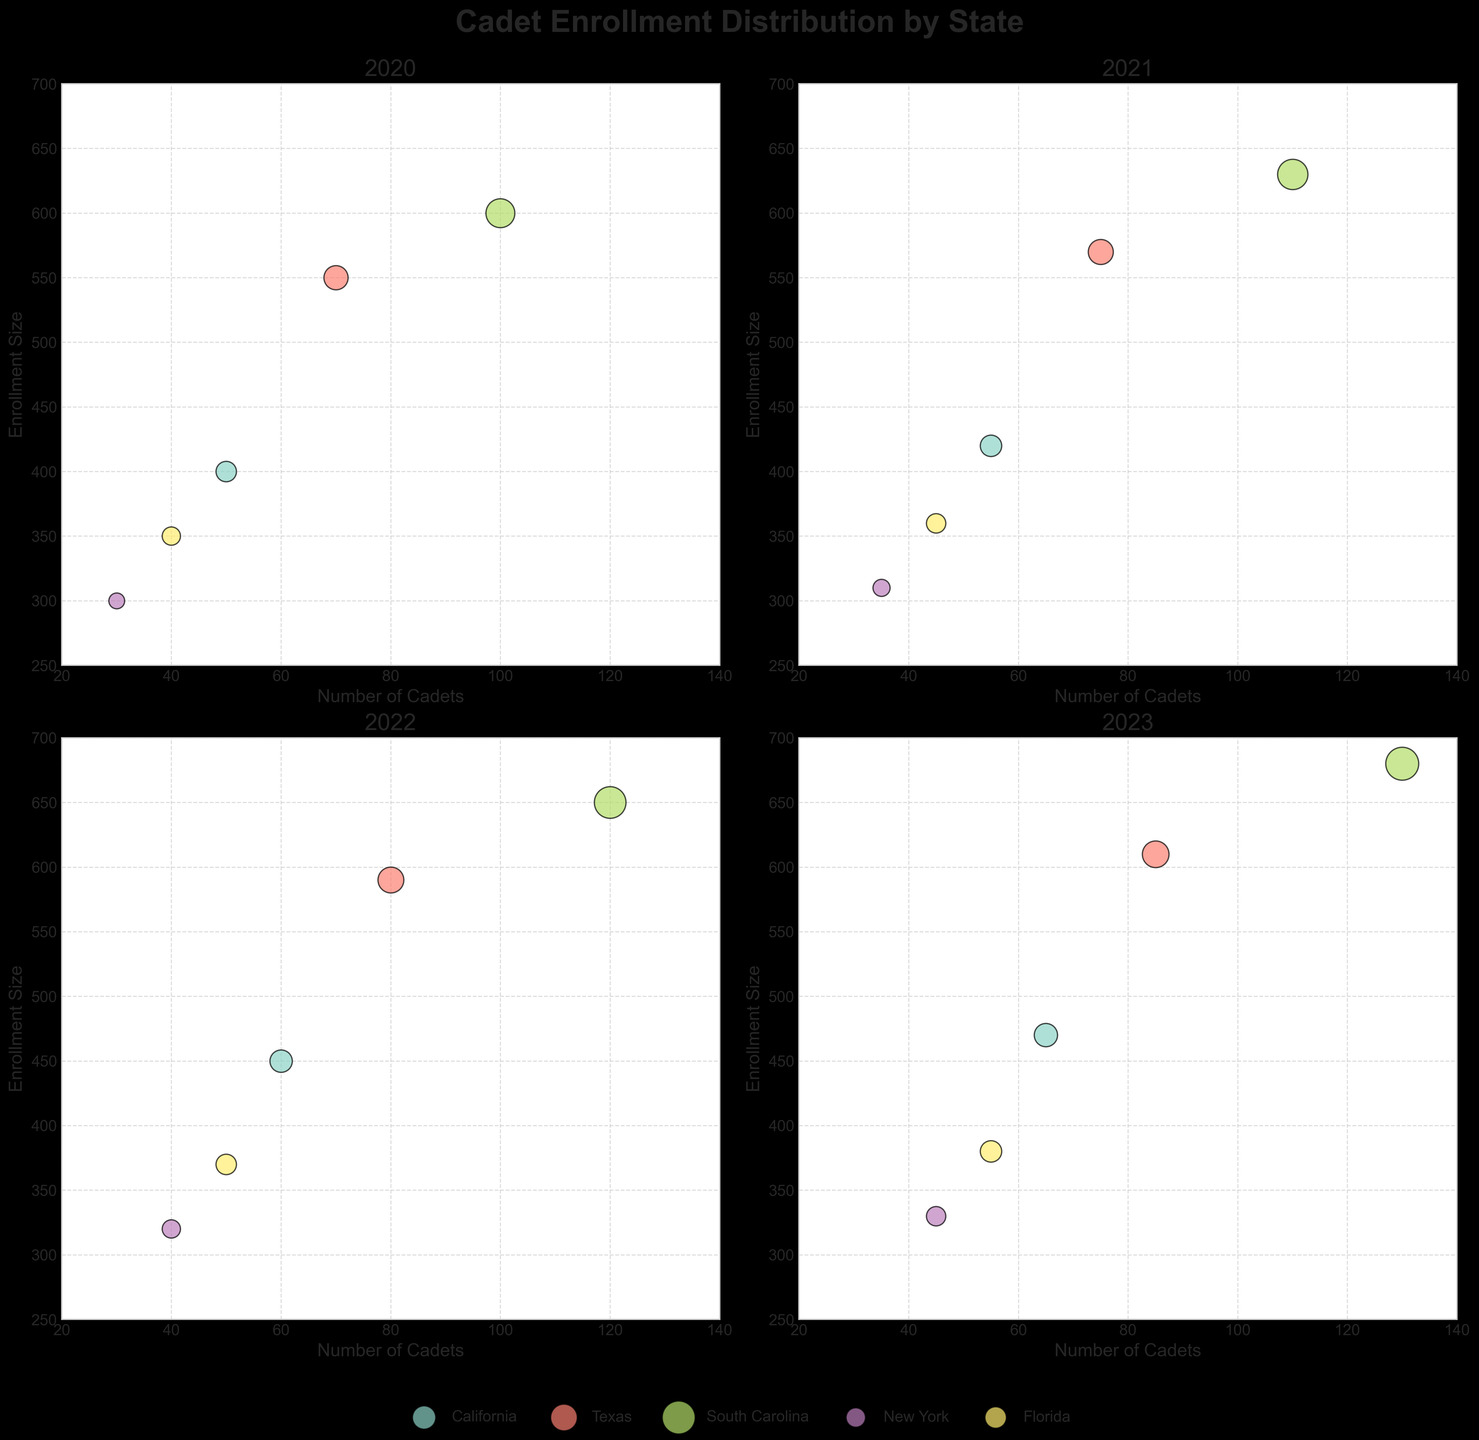Which year has the highest cadet enrollment for South Carolina? By looking at the bubble sizes for South Carolina across all subplots, 2023 has the largest bubble, indicating the highest cadet enrollment.
Answer: 2023 What is the title of the figure? The title is prominently displayed at the top of the figure.
Answer: Cadet Enrollment Distribution by State How many states are represented in each year? There are five distinct colored bubbles representing five states in each subplot.
Answer: 5 Compare the cadet enrollment in California and Texas in 2021. Which state has more cadets? By comparing the bubble sizes for California and Texas in the 2021 subplot, Texas has a larger bubble, indicating more cadets.
Answer: Texas What is the enrollment size for New York in 2022? Look for the bubble corresponding to New York in the 2022 subplot and note the y-axis value.
Answer: 320 Which state shows a consistent increase in cadet numbers from 2020 to 2023? Observing the four subplots chronologically, South Carolina's bubbles increase in size each year, indicating a consistent rise.
Answer: South Carolina Find the average cadet count for Florida from 2020 to 2023. Add the cadet counts for Florida from each year and divide by four: (40 + 45 + 50 + 55) / 4 = 190 / 4 = 47.5
Answer: 47.5 In which year does South Carolina have the largest cadet enrollment relative to the other states? By comparing the bubble sizes in each subplot, 2023 shows South Carolina with the largest bubble for that year.
Answer: 2023 What trend can be identified for New York's cadet counts from 2020 to 2023? Reviewing New York's bubble sizes across the years, we note a steady increase from 30 to 45.
Answer: Increasing Between California and Florida in 2023, which state has a larger enrollment size? Check the y-axis value for the bubbles representing California and Florida in 2023, where California's bubble is higher.
Answer: California 